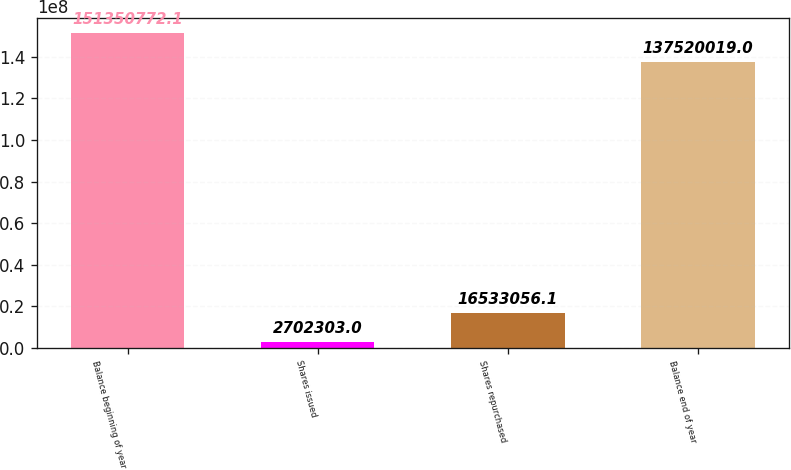Convert chart. <chart><loc_0><loc_0><loc_500><loc_500><bar_chart><fcel>Balance beginning of year<fcel>Shares issued<fcel>Shares repurchased<fcel>Balance end of year<nl><fcel>1.51351e+08<fcel>2.7023e+06<fcel>1.65331e+07<fcel>1.3752e+08<nl></chart> 